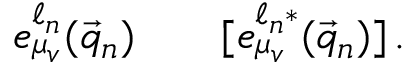<formula> <loc_0><loc_0><loc_500><loc_500>e _ { \mu _ { v } } ^ { \ell _ { n } } ( \vec { q } _ { n } ) \quad [ e _ { \mu _ { v } } ^ { \ell _ { n } * } ( \vec { q } _ { n } ) ] \, .</formula> 